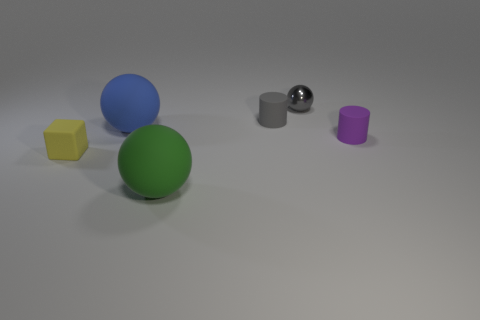Add 1 big matte objects. How many objects exist? 7 Subtract all cylinders. How many objects are left? 4 Add 5 balls. How many balls are left? 8 Add 4 large things. How many large things exist? 6 Subtract 1 yellow cubes. How many objects are left? 5 Subtract all purple objects. Subtract all big green balls. How many objects are left? 4 